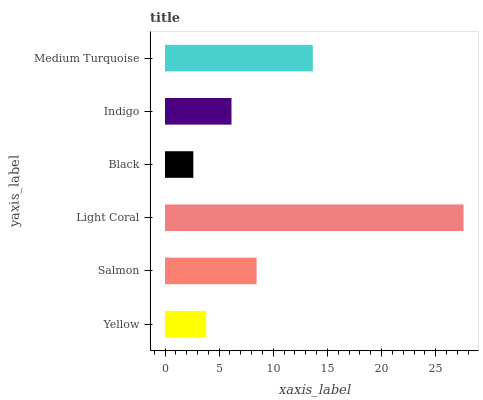Is Black the minimum?
Answer yes or no. Yes. Is Light Coral the maximum?
Answer yes or no. Yes. Is Salmon the minimum?
Answer yes or no. No. Is Salmon the maximum?
Answer yes or no. No. Is Salmon greater than Yellow?
Answer yes or no. Yes. Is Yellow less than Salmon?
Answer yes or no. Yes. Is Yellow greater than Salmon?
Answer yes or no. No. Is Salmon less than Yellow?
Answer yes or no. No. Is Salmon the high median?
Answer yes or no. Yes. Is Indigo the low median?
Answer yes or no. Yes. Is Medium Turquoise the high median?
Answer yes or no. No. Is Light Coral the low median?
Answer yes or no. No. 